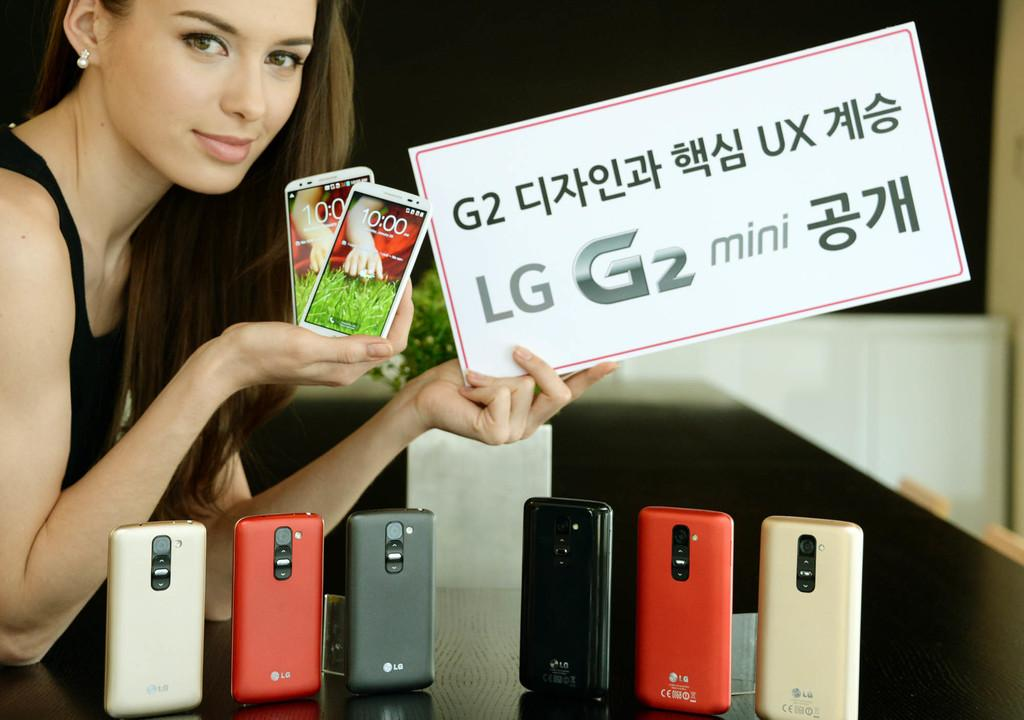<image>
Offer a succinct explanation of the picture presented. A lady holds two phones while 6 LG phones sit on the table infront of her. 